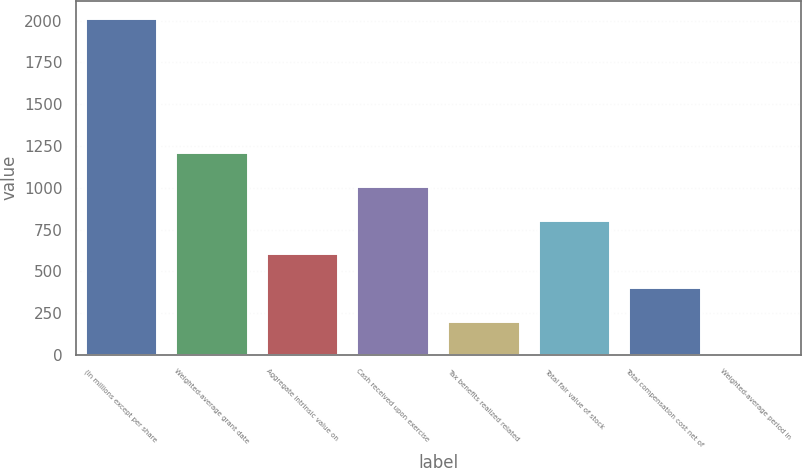<chart> <loc_0><loc_0><loc_500><loc_500><bar_chart><fcel>(In millions except per share<fcel>Weighted-average grant date<fcel>Aggregate intrinsic value on<fcel>Cash received upon exercise<fcel>Tax benefits realized related<fcel>Total fair value of stock<fcel>Total compensation cost net of<fcel>Weighted-average period in<nl><fcel>2019<fcel>1212.2<fcel>607.1<fcel>1010.5<fcel>203.7<fcel>808.8<fcel>405.4<fcel>2<nl></chart> 